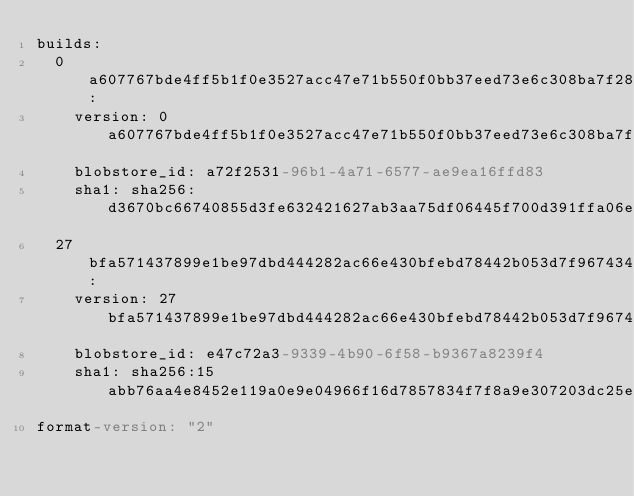<code> <loc_0><loc_0><loc_500><loc_500><_YAML_>builds:
  0a607767bde4ff5b1f0e3527acc47e71b550f0bb37eed73e6c308ba7f289a588:
    version: 0a607767bde4ff5b1f0e3527acc47e71b550f0bb37eed73e6c308ba7f289a588
    blobstore_id: a72f2531-96b1-4a71-6577-ae9ea16ffd83
    sha1: sha256:d3670bc66740855d3fe632421627ab3aa75df06445f700d391ffa06eceaac4da
  27bfa571437899e1be97dbd444282ac66e430bfebd78442b053d7f96743456cc:
    version: 27bfa571437899e1be97dbd444282ac66e430bfebd78442b053d7f96743456cc
    blobstore_id: e47c72a3-9339-4b90-6f58-b9367a8239f4
    sha1: sha256:15abb76aa4e8452e119a0e9e04966f16d7857834f7f8a9e307203dc25e546d2a
format-version: "2"
</code> 